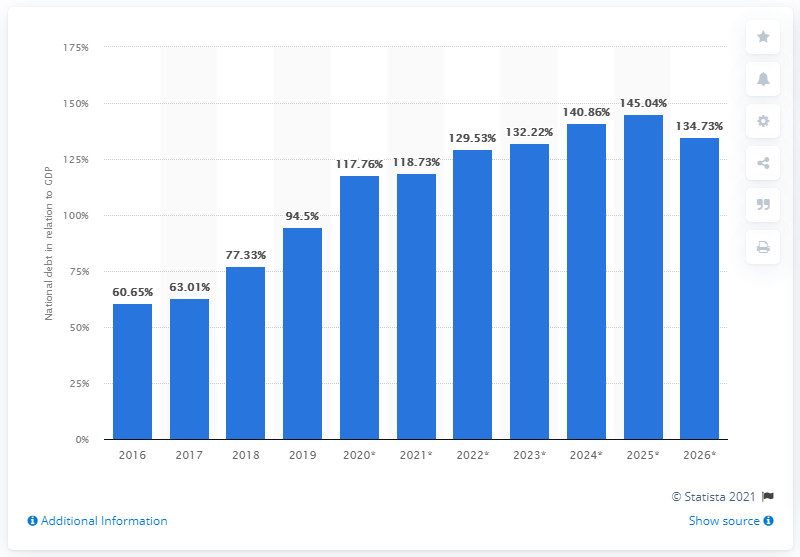Draw attention to some important aspects in this diagram. In 2019, the national debt of Zambia accounted for 94.5% of the country's Gross Domestic Product (GDP). 